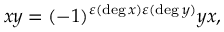Convert formula to latex. <formula><loc_0><loc_0><loc_500><loc_500>x y = ( - 1 ) ^ { \varepsilon ( \deg x ) \varepsilon ( \deg y ) } y x ,</formula> 